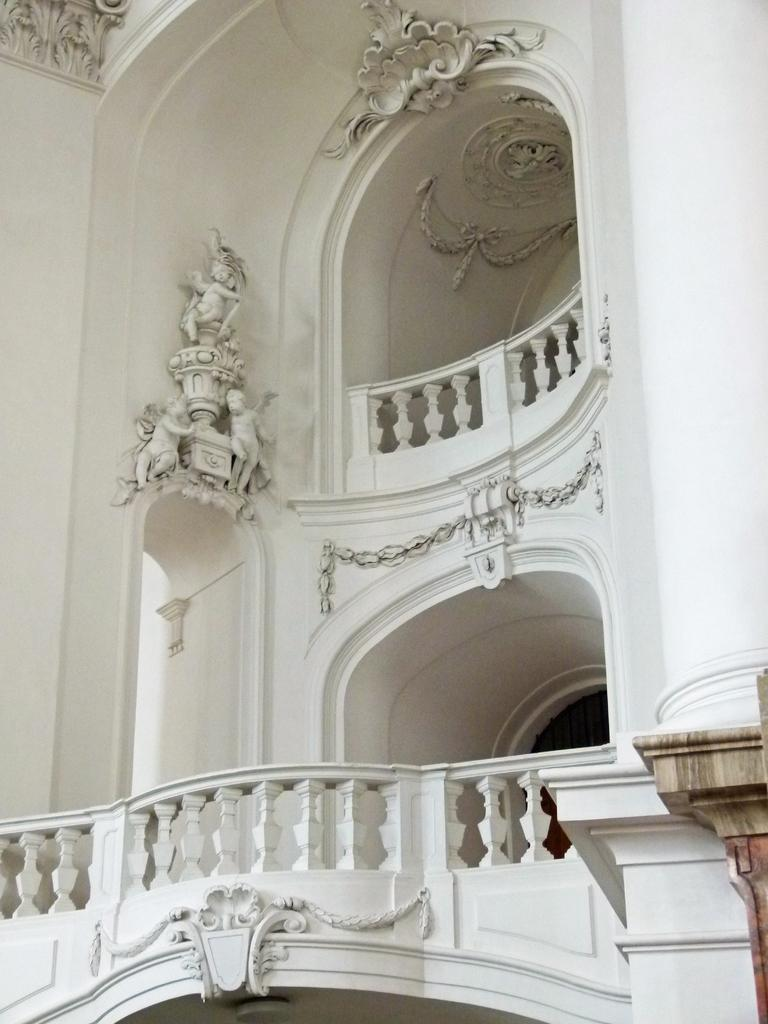What type of structure is visible in the image? There is a building in the image. What type of mountain can be seen in the background of the image? There is no mountain visible in the image; it only features a building. What level of security is present in the building in the image? The provided facts do not mention any security features or the purpose of the building, so it is not possible to determine the level of security. 